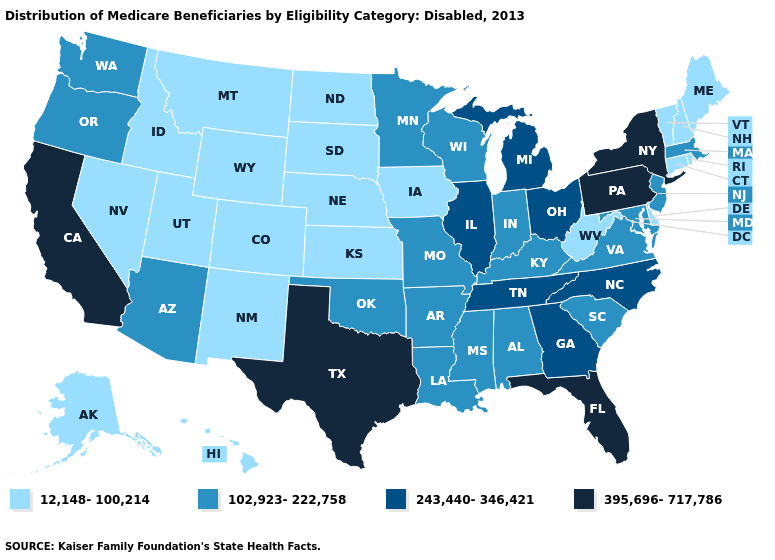Which states have the highest value in the USA?
Quick response, please. California, Florida, New York, Pennsylvania, Texas. Does North Carolina have the highest value in the USA?
Concise answer only. No. Which states hav the highest value in the MidWest?
Write a very short answer. Illinois, Michigan, Ohio. Which states have the lowest value in the West?
Quick response, please. Alaska, Colorado, Hawaii, Idaho, Montana, Nevada, New Mexico, Utah, Wyoming. What is the value of Minnesota?
Concise answer only. 102,923-222,758. What is the value of Alabama?
Answer briefly. 102,923-222,758. Does Oklahoma have the lowest value in the USA?
Give a very brief answer. No. Which states have the lowest value in the USA?
Be succinct. Alaska, Colorado, Connecticut, Delaware, Hawaii, Idaho, Iowa, Kansas, Maine, Montana, Nebraska, Nevada, New Hampshire, New Mexico, North Dakota, Rhode Island, South Dakota, Utah, Vermont, West Virginia, Wyoming. What is the lowest value in the South?
Keep it brief. 12,148-100,214. What is the highest value in the USA?
Give a very brief answer. 395,696-717,786. How many symbols are there in the legend?
Quick response, please. 4. How many symbols are there in the legend?
Be succinct. 4. Name the states that have a value in the range 395,696-717,786?
Give a very brief answer. California, Florida, New York, Pennsylvania, Texas. Among the states that border Missouri , does Illinois have the highest value?
Be succinct. Yes. Among the states that border Rhode Island , does Connecticut have the lowest value?
Give a very brief answer. Yes. 